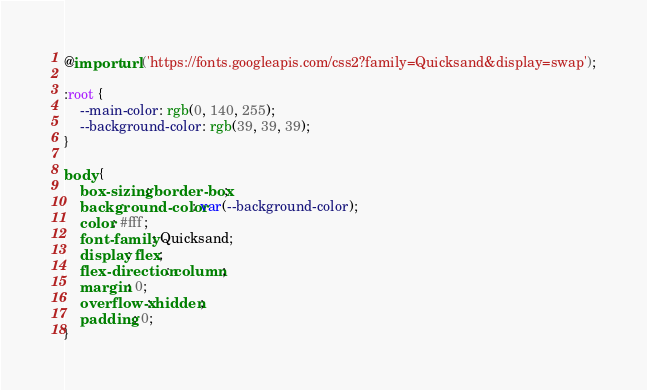Convert code to text. <code><loc_0><loc_0><loc_500><loc_500><_CSS_>@import url('https://fonts.googleapis.com/css2?family=Quicksand&display=swap');

:root {
	--main-color: rgb(0, 140, 255);
	--background-color: rgb(39, 39, 39);
}

body {
	box-sizing: border-box;
	background-color: var(--background-color);
	color: #fff;
	font-family: Quicksand;
	display: flex;
	flex-direction: column;
	margin: 0;
	overflow-x: hidden;
	padding: 0;
}
</code> 